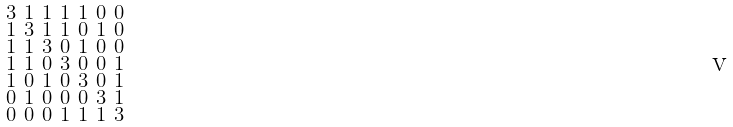<formula> <loc_0><loc_0><loc_500><loc_500>\begin{smallmatrix} 3 & 1 & 1 & 1 & 1 & 0 & 0 \\ 1 & 3 & 1 & 1 & 0 & 1 & 0 \\ 1 & 1 & 3 & 0 & 1 & 0 & 0 \\ 1 & 1 & 0 & 3 & 0 & 0 & 1 \\ 1 & 0 & 1 & 0 & 3 & 0 & 1 \\ 0 & 1 & 0 & 0 & 0 & 3 & 1 \\ 0 & 0 & 0 & 1 & 1 & 1 & 3 \end{smallmatrix}</formula> 